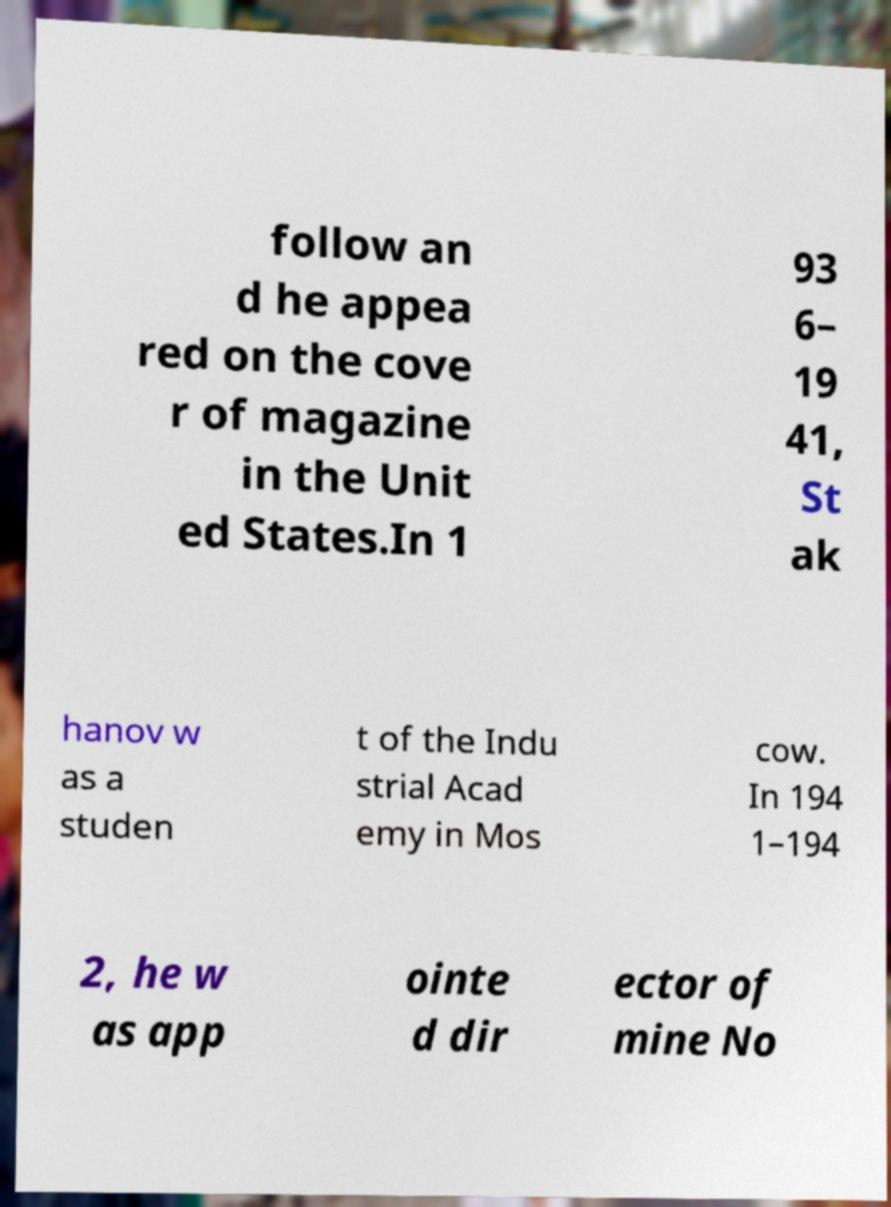What messages or text are displayed in this image? I need them in a readable, typed format. follow an d he appea red on the cove r of magazine in the Unit ed States.In 1 93 6– 19 41, St ak hanov w as a studen t of the Indu strial Acad emy in Mos cow. In 194 1–194 2, he w as app ointe d dir ector of mine No 